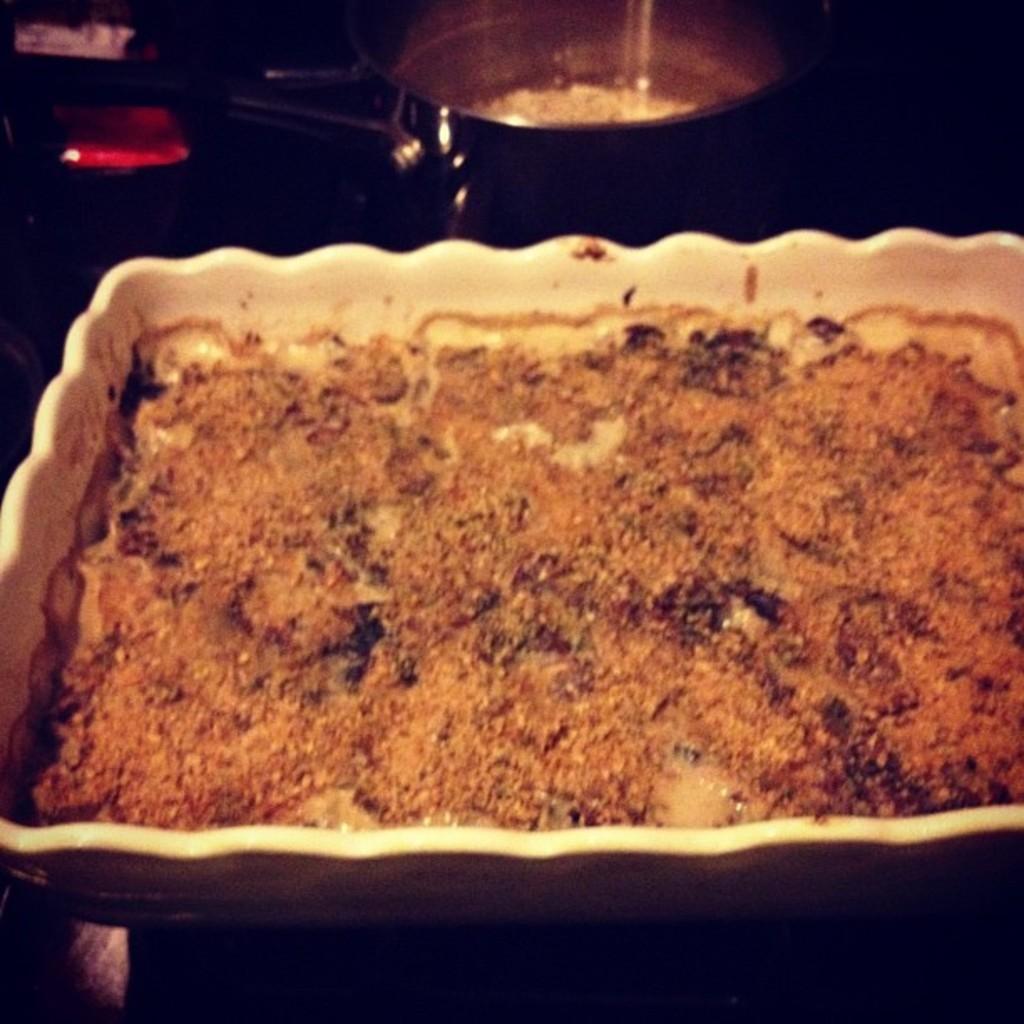Could you give a brief overview of what you see in this image? Here there is something in the container, here there is vessel. 